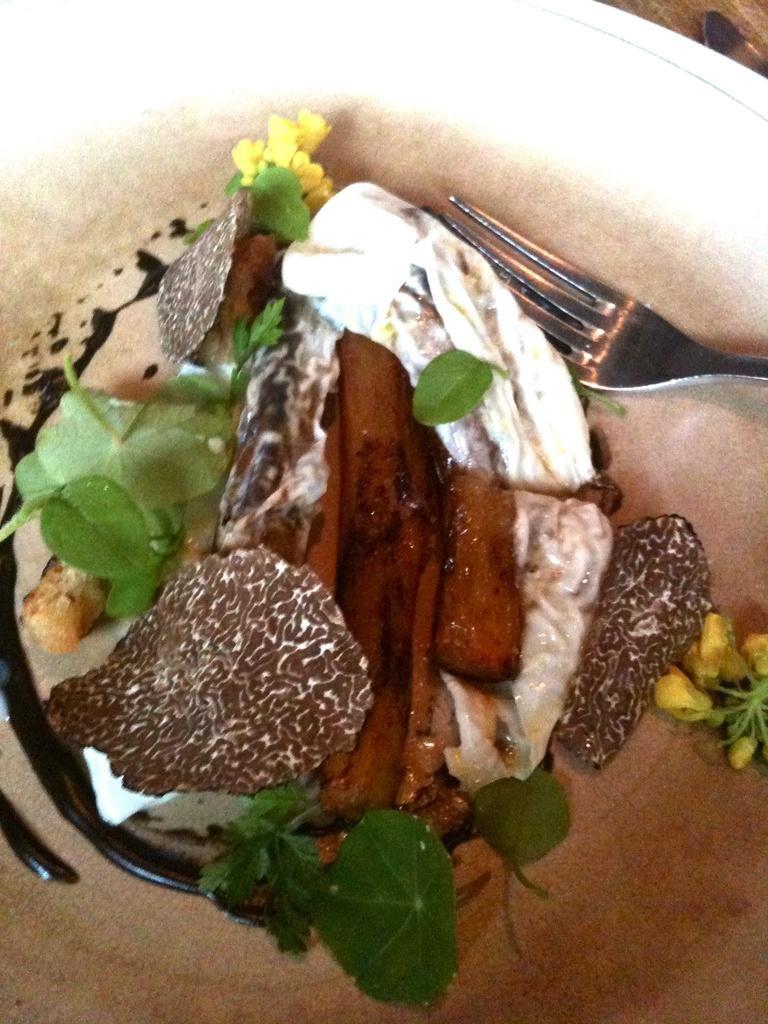Can you describe this image briefly? In the picture we can see a bowl which is white in color with an ice cream and some leaf garnish on it with a fork in it. 